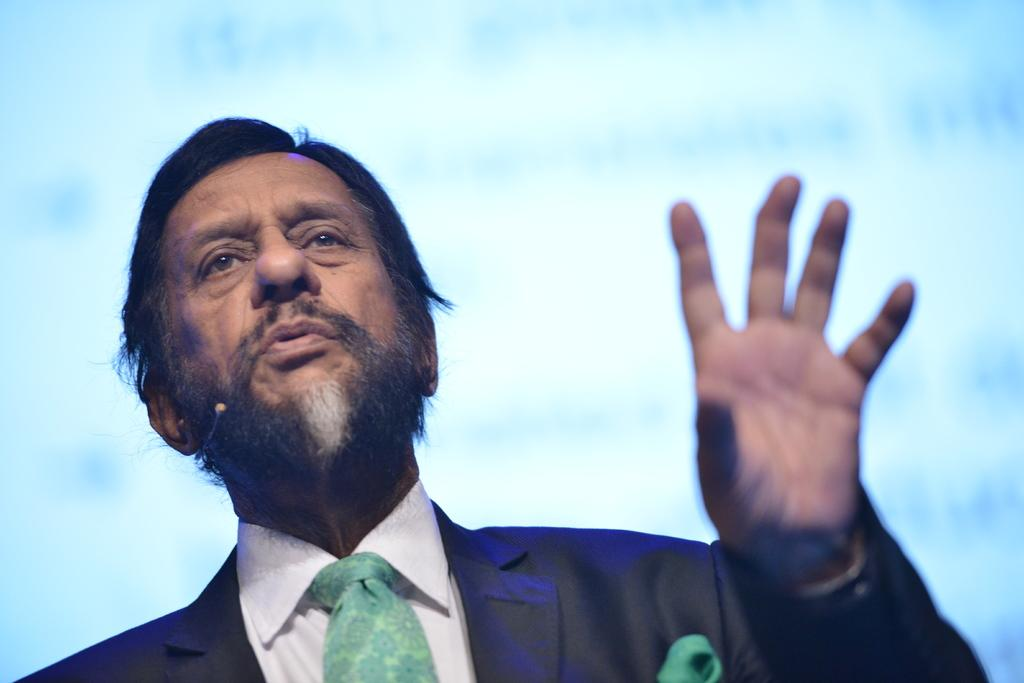What is present in the image? There is a person in the image. What is the person wearing? The person is wearing a black color suit. Can you see any seashore or basket in the image? No, there is no seashore or basket present in the image. What type of food is the person eating in the image? The provided facts do not mention any food or the person's mouth, so it cannot be determined from the image. 